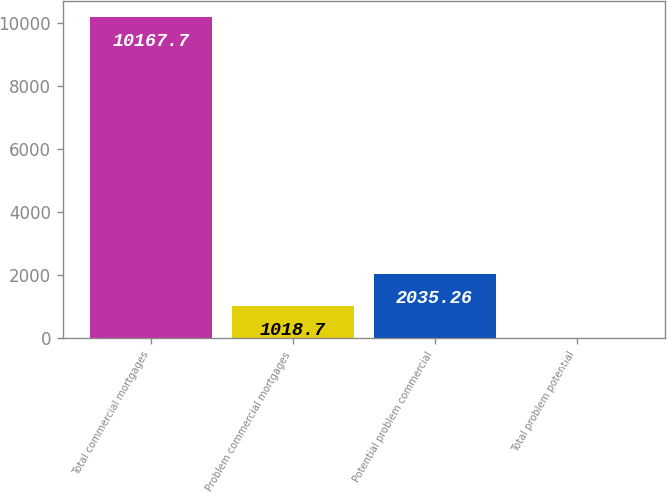<chart> <loc_0><loc_0><loc_500><loc_500><bar_chart><fcel>Total commercial mortgages<fcel>Problem commercial mortgages<fcel>Potential problem commercial<fcel>Total problem potential<nl><fcel>10167.7<fcel>1018.7<fcel>2035.26<fcel>2.14<nl></chart> 